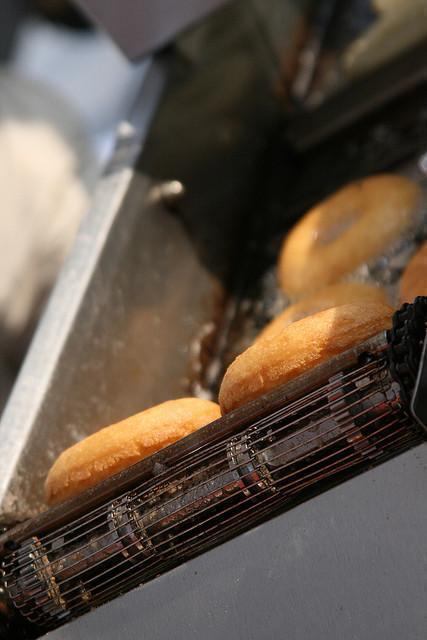What step of donut creation is this scene at?
Select the accurate answer and provide justification: `Answer: choice
Rationale: srationale.`
Options: Frying, cutting, adding sprinkles, adding glaze. Answer: frying.
Rationale: Donuts are on a metal surface in front of others that are sitting in oil. 